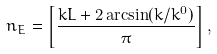<formula> <loc_0><loc_0><loc_500><loc_500>n _ { E } = \left [ \frac { k L + 2 \arcsin ( k / k ^ { 0 } ) } { \pi } \right ] ,</formula> 